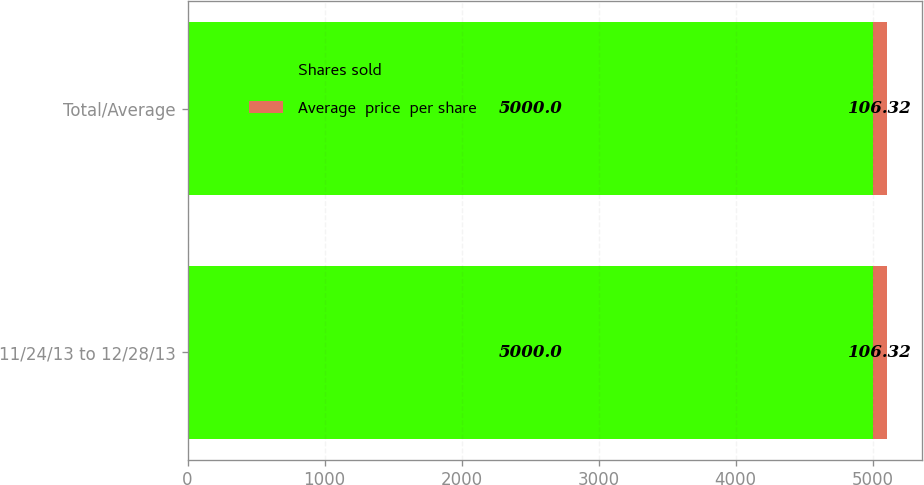Convert chart to OTSL. <chart><loc_0><loc_0><loc_500><loc_500><stacked_bar_chart><ecel><fcel>11/24/13 to 12/28/13<fcel>Total/Average<nl><fcel>Shares sold<fcel>5000<fcel>5000<nl><fcel>Average  price  per share<fcel>106.32<fcel>106.32<nl></chart> 